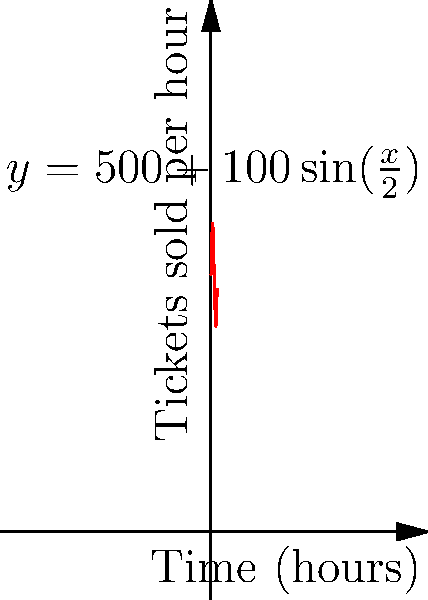Your sister's favorite pop star is holding a 12-hour virtual concert. The rate of ticket sales (in tickets per hour) is modeled by the function $f(x) = 500 + 100\sin(\frac{x}{2})$, where $x$ is the number of hours since ticket sales began. Despite your skepticism, you're curious about the total number of tickets sold. Calculate the total number of tickets sold during the 12-hour period. To find the total number of tickets sold, we need to integrate the rate function over the 12-hour period:

1) Set up the definite integral:
   $$\int_0^{12} (500 + 100\sin(\frac{x}{2})) dx$$

2) Split the integral:
   $$\int_0^{12} 500 dx + \int_0^{12} 100\sin(\frac{x}{2}) dx$$

3) Evaluate the first part:
   $$500x \bigg|_0^{12} = 6000$$

4) For the second part, use substitution. Let $u = \frac{x}{2}$, so $du = \frac{1}{2}dx$ and $dx = 2du$:
   $$200\int_0^6 \sin(u) du$$

5) Evaluate:
   $$-200\cos(u) \bigg|_0^6 = -200(\cos(6) - \cos(0)) = -200(\cos(6) - 1)$$

6) Add the results from steps 3 and 5:
   $$6000 - 200(\cos(6) - 1)$$

7) Calculate the final value:
   $$6000 - 200(-0.96 - 1) \approx 6392$$
Answer: 6392 tickets 